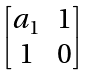Convert formula to latex. <formula><loc_0><loc_0><loc_500><loc_500>\begin{bmatrix} a _ { 1 } & 1 \\ 1 & 0 \end{bmatrix}</formula> 